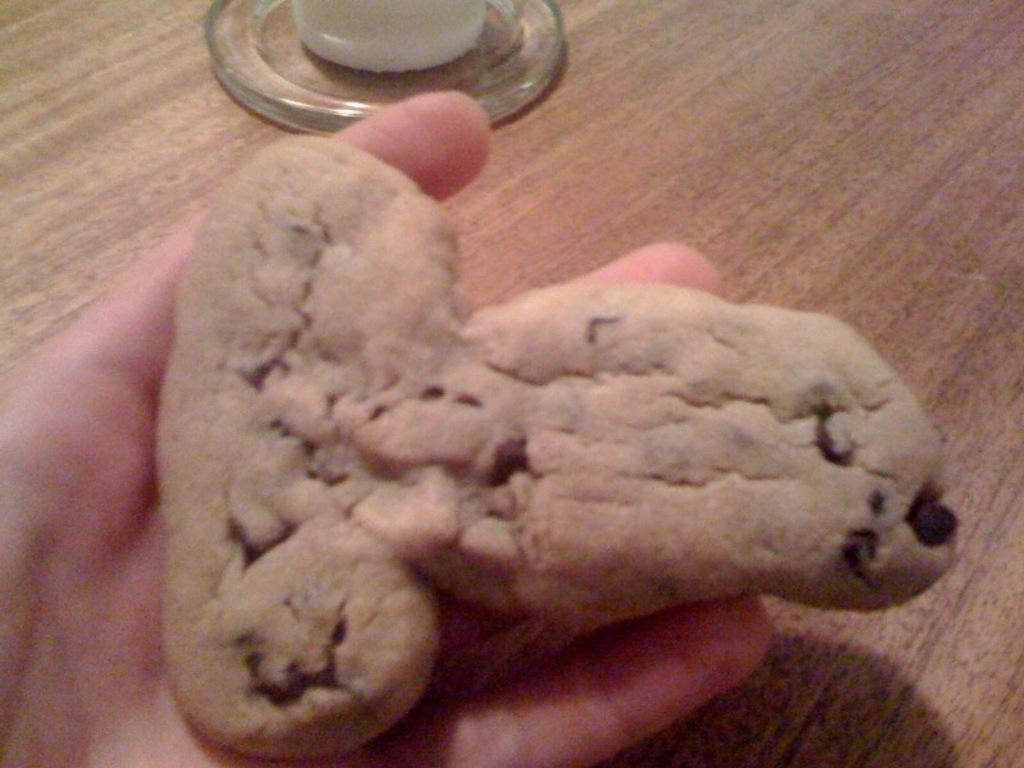Could you give a brief overview of what you see in this image? In this image there is an object in the hand of the person and there is a glass object which is on the surface which is brown in colour. 